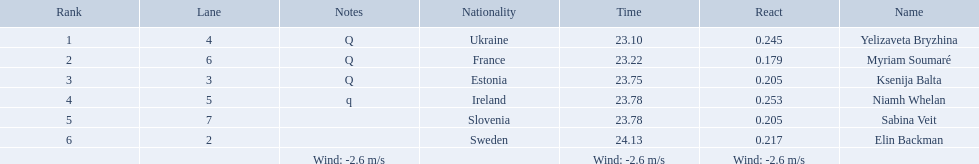What are all the names? Yelizaveta Bryzhina, Myriam Soumaré, Ksenija Balta, Niamh Whelan, Sabina Veit, Elin Backman. What were their finishing times? 23.10, 23.22, 23.75, 23.78, 23.78, 24.13. And which time was reached by ellen backman? 24.13. 